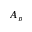<formula> <loc_0><loc_0><loc_500><loc_500>A _ { p }</formula> 